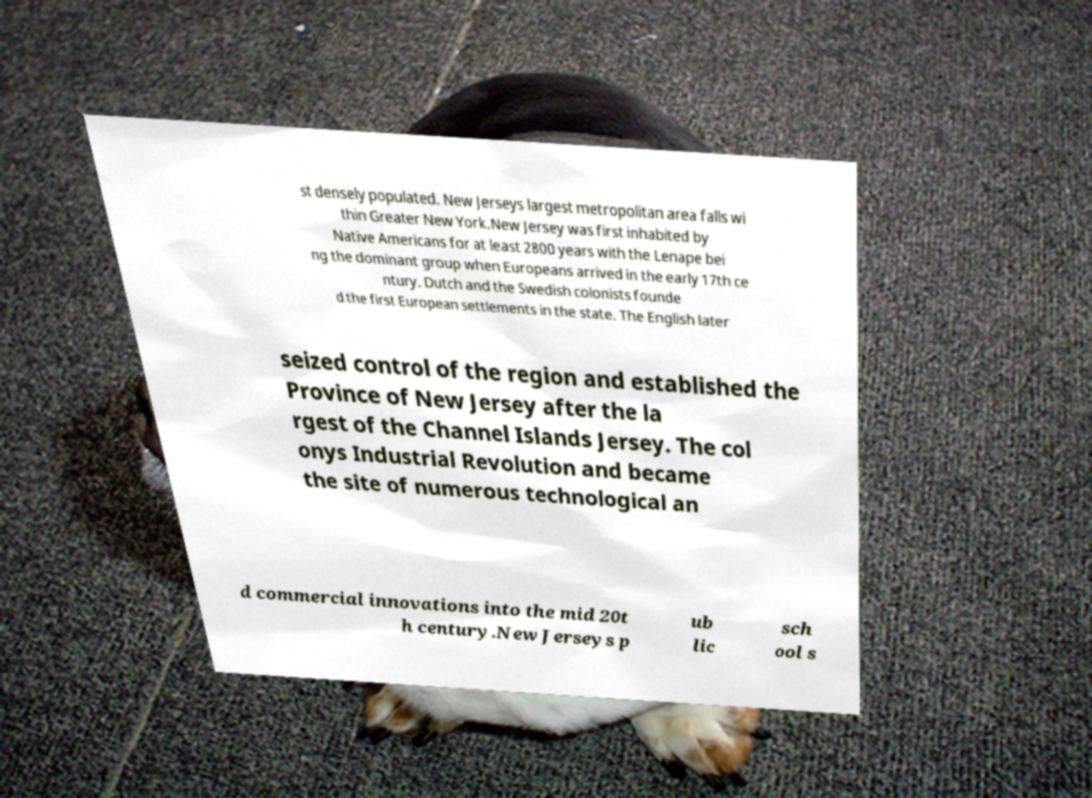For documentation purposes, I need the text within this image transcribed. Could you provide that? st densely populated. New Jerseys largest metropolitan area falls wi thin Greater New York.New Jersey was first inhabited by Native Americans for at least 2800 years with the Lenape bei ng the dominant group when Europeans arrived in the early 17th ce ntury. Dutch and the Swedish colonists founde d the first European settlements in the state. The English later seized control of the region and established the Province of New Jersey after the la rgest of the Channel Islands Jersey. The col onys Industrial Revolution and became the site of numerous technological an d commercial innovations into the mid 20t h century.New Jerseys p ub lic sch ool s 